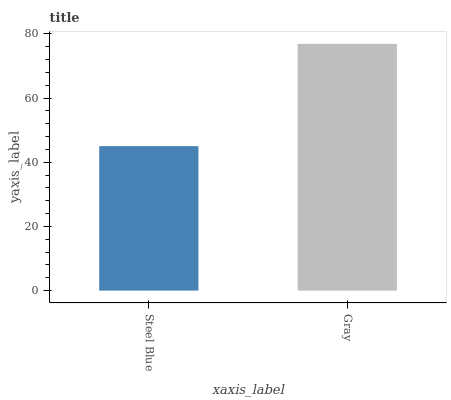Is Steel Blue the minimum?
Answer yes or no. Yes. Is Gray the maximum?
Answer yes or no. Yes. Is Gray the minimum?
Answer yes or no. No. Is Gray greater than Steel Blue?
Answer yes or no. Yes. Is Steel Blue less than Gray?
Answer yes or no. Yes. Is Steel Blue greater than Gray?
Answer yes or no. No. Is Gray less than Steel Blue?
Answer yes or no. No. Is Gray the high median?
Answer yes or no. Yes. Is Steel Blue the low median?
Answer yes or no. Yes. Is Steel Blue the high median?
Answer yes or no. No. Is Gray the low median?
Answer yes or no. No. 